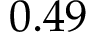Convert formula to latex. <formula><loc_0><loc_0><loc_500><loc_500>0 . 4 9</formula> 